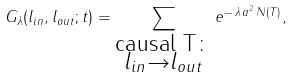<formula> <loc_0><loc_0><loc_500><loc_500>G _ { \lambda } ( l _ { i n } , l _ { o u t } ; t ) = \sum _ { \substack { \text {causal T} \colon \\ l _ { i n } \rightarrow l _ { o u t } } } e ^ { - \, \lambda \, a ^ { 2 } \, N ( T ) } ,</formula> 